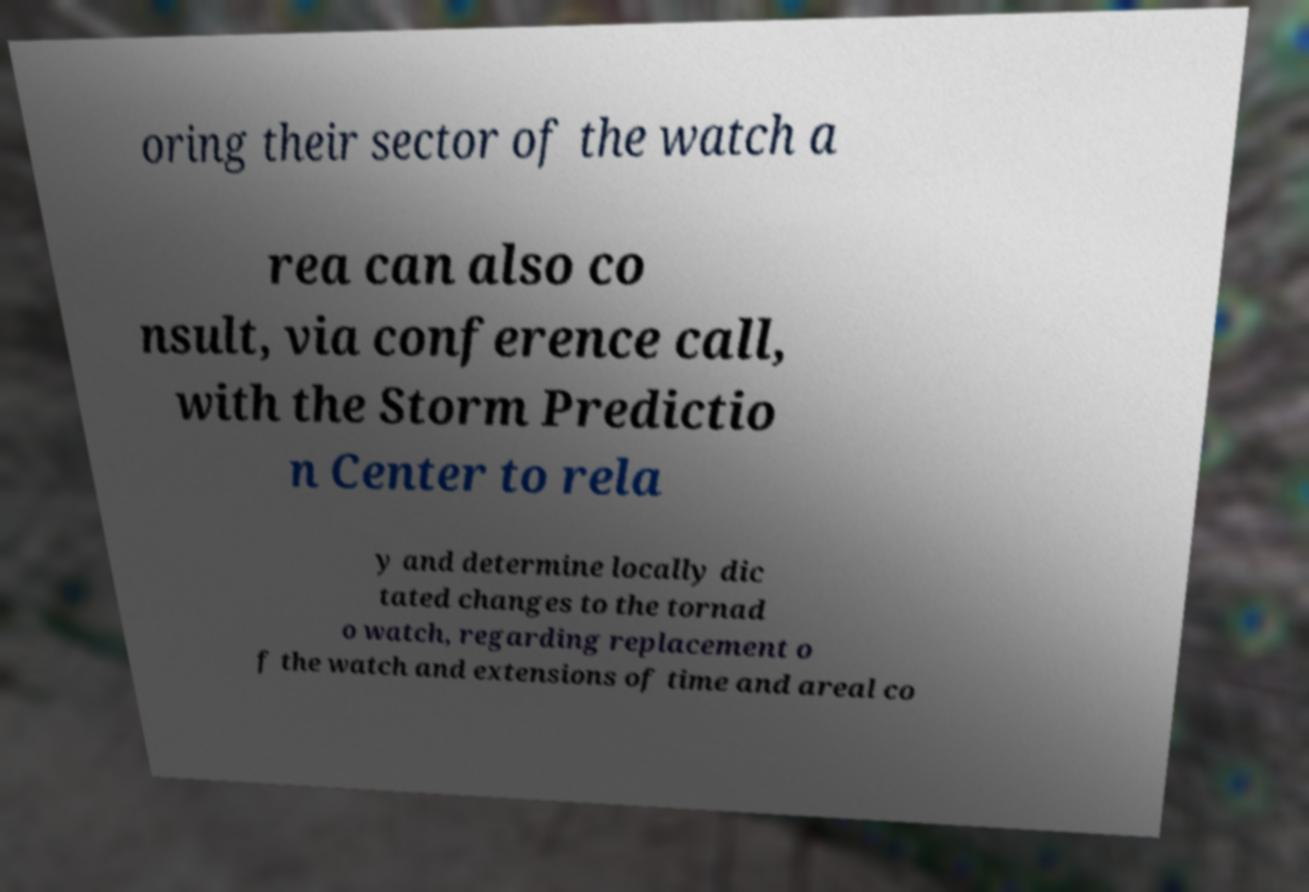Could you assist in decoding the text presented in this image and type it out clearly? oring their sector of the watch a rea can also co nsult, via conference call, with the Storm Predictio n Center to rela y and determine locally dic tated changes to the tornad o watch, regarding replacement o f the watch and extensions of time and areal co 